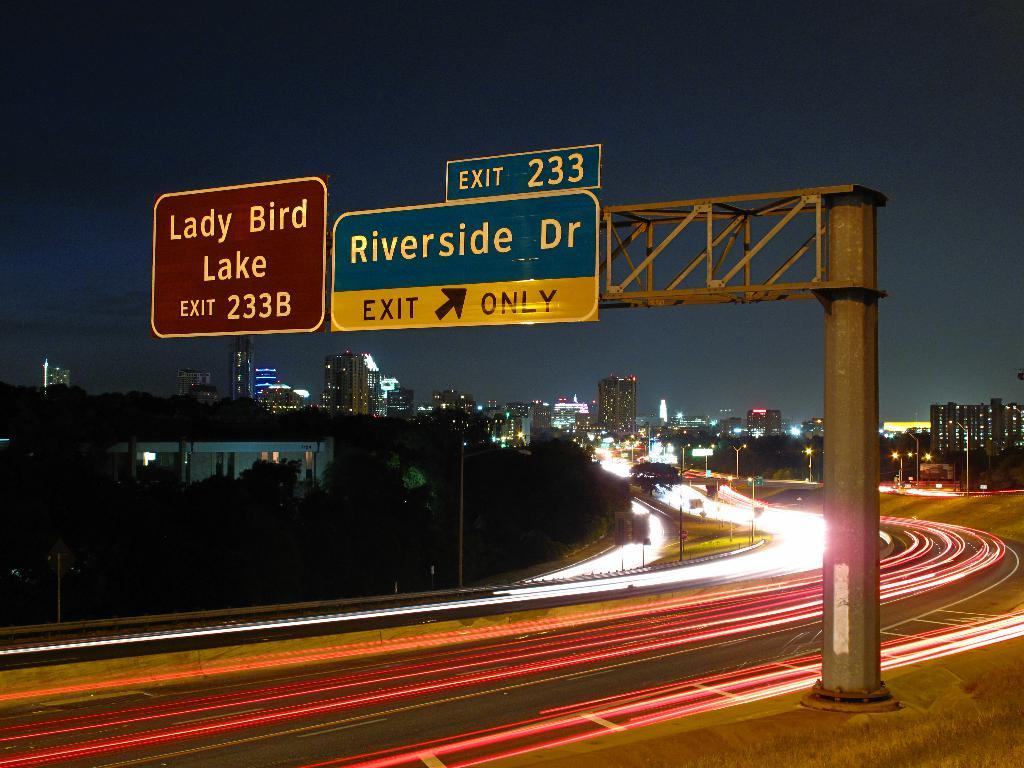<image>
Share a concise interpretation of the image provided. A sign above the highway says exit 233 will bring you to Riverside Dr. 